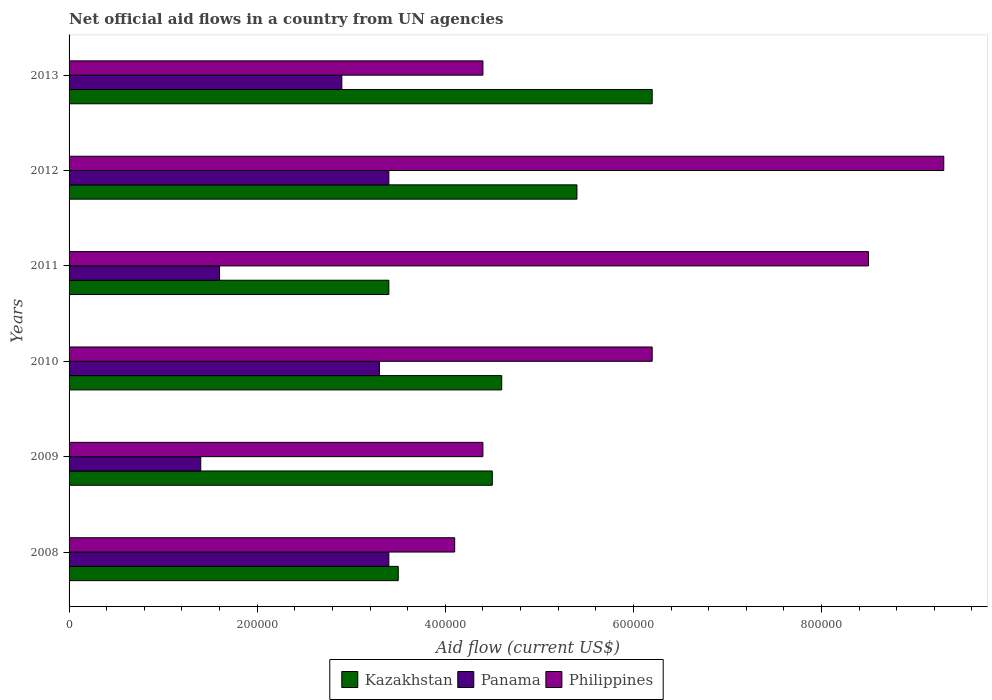How many different coloured bars are there?
Ensure brevity in your answer.  3. How many groups of bars are there?
Your answer should be compact. 6. Are the number of bars per tick equal to the number of legend labels?
Keep it short and to the point. Yes. Are the number of bars on each tick of the Y-axis equal?
Ensure brevity in your answer.  Yes. How many bars are there on the 1st tick from the top?
Offer a very short reply. 3. What is the net official aid flow in Kazakhstan in 2009?
Offer a very short reply. 4.50e+05. Across all years, what is the maximum net official aid flow in Panama?
Ensure brevity in your answer.  3.40e+05. Across all years, what is the minimum net official aid flow in Panama?
Ensure brevity in your answer.  1.40e+05. In which year was the net official aid flow in Panama minimum?
Provide a succinct answer. 2009. What is the total net official aid flow in Kazakhstan in the graph?
Provide a short and direct response. 2.76e+06. What is the difference between the net official aid flow in Kazakhstan in 2008 and that in 2012?
Make the answer very short. -1.90e+05. What is the difference between the net official aid flow in Kazakhstan in 2009 and the net official aid flow in Panama in 2012?
Offer a terse response. 1.10e+05. What is the average net official aid flow in Panama per year?
Offer a very short reply. 2.67e+05. In the year 2011, what is the difference between the net official aid flow in Kazakhstan and net official aid flow in Philippines?
Your answer should be very brief. -5.10e+05. In how many years, is the net official aid flow in Philippines greater than 760000 US$?
Your response must be concise. 2. What is the ratio of the net official aid flow in Philippines in 2008 to that in 2009?
Offer a very short reply. 0.93. Is the net official aid flow in Panama in 2008 less than that in 2013?
Provide a succinct answer. No. Is the difference between the net official aid flow in Kazakhstan in 2008 and 2011 greater than the difference between the net official aid flow in Philippines in 2008 and 2011?
Your answer should be compact. Yes. What is the difference between the highest and the lowest net official aid flow in Kazakhstan?
Your answer should be compact. 2.80e+05. In how many years, is the net official aid flow in Panama greater than the average net official aid flow in Panama taken over all years?
Provide a succinct answer. 4. What does the 3rd bar from the bottom in 2009 represents?
Your answer should be compact. Philippines. Is it the case that in every year, the sum of the net official aid flow in Philippines and net official aid flow in Panama is greater than the net official aid flow in Kazakhstan?
Make the answer very short. Yes. How many years are there in the graph?
Give a very brief answer. 6. What is the difference between two consecutive major ticks on the X-axis?
Provide a short and direct response. 2.00e+05. Does the graph contain any zero values?
Your answer should be compact. No. Does the graph contain grids?
Offer a very short reply. No. Where does the legend appear in the graph?
Offer a terse response. Bottom center. How many legend labels are there?
Ensure brevity in your answer.  3. What is the title of the graph?
Offer a very short reply. Net official aid flows in a country from UN agencies. What is the Aid flow (current US$) in Kazakhstan in 2008?
Your answer should be compact. 3.50e+05. What is the Aid flow (current US$) of Philippines in 2008?
Offer a very short reply. 4.10e+05. What is the Aid flow (current US$) of Panama in 2009?
Provide a short and direct response. 1.40e+05. What is the Aid flow (current US$) of Philippines in 2009?
Your answer should be compact. 4.40e+05. What is the Aid flow (current US$) in Panama in 2010?
Offer a terse response. 3.30e+05. What is the Aid flow (current US$) of Philippines in 2010?
Offer a terse response. 6.20e+05. What is the Aid flow (current US$) of Kazakhstan in 2011?
Give a very brief answer. 3.40e+05. What is the Aid flow (current US$) of Panama in 2011?
Ensure brevity in your answer.  1.60e+05. What is the Aid flow (current US$) of Philippines in 2011?
Provide a short and direct response. 8.50e+05. What is the Aid flow (current US$) of Kazakhstan in 2012?
Offer a very short reply. 5.40e+05. What is the Aid flow (current US$) of Panama in 2012?
Provide a short and direct response. 3.40e+05. What is the Aid flow (current US$) of Philippines in 2012?
Your response must be concise. 9.30e+05. What is the Aid flow (current US$) of Kazakhstan in 2013?
Offer a terse response. 6.20e+05. What is the Aid flow (current US$) of Philippines in 2013?
Your answer should be compact. 4.40e+05. Across all years, what is the maximum Aid flow (current US$) in Kazakhstan?
Ensure brevity in your answer.  6.20e+05. Across all years, what is the maximum Aid flow (current US$) in Panama?
Offer a very short reply. 3.40e+05. Across all years, what is the maximum Aid flow (current US$) in Philippines?
Your answer should be compact. 9.30e+05. Across all years, what is the minimum Aid flow (current US$) in Panama?
Give a very brief answer. 1.40e+05. Across all years, what is the minimum Aid flow (current US$) in Philippines?
Offer a terse response. 4.10e+05. What is the total Aid flow (current US$) of Kazakhstan in the graph?
Your answer should be compact. 2.76e+06. What is the total Aid flow (current US$) in Panama in the graph?
Provide a succinct answer. 1.60e+06. What is the total Aid flow (current US$) in Philippines in the graph?
Your answer should be very brief. 3.69e+06. What is the difference between the Aid flow (current US$) in Kazakhstan in 2008 and that in 2009?
Provide a short and direct response. -1.00e+05. What is the difference between the Aid flow (current US$) of Panama in 2008 and that in 2010?
Make the answer very short. 10000. What is the difference between the Aid flow (current US$) of Philippines in 2008 and that in 2010?
Give a very brief answer. -2.10e+05. What is the difference between the Aid flow (current US$) in Kazakhstan in 2008 and that in 2011?
Give a very brief answer. 10000. What is the difference between the Aid flow (current US$) in Philippines in 2008 and that in 2011?
Ensure brevity in your answer.  -4.40e+05. What is the difference between the Aid flow (current US$) of Kazakhstan in 2008 and that in 2012?
Provide a succinct answer. -1.90e+05. What is the difference between the Aid flow (current US$) in Panama in 2008 and that in 2012?
Your response must be concise. 0. What is the difference between the Aid flow (current US$) of Philippines in 2008 and that in 2012?
Your answer should be compact. -5.20e+05. What is the difference between the Aid flow (current US$) of Kazakhstan in 2008 and that in 2013?
Ensure brevity in your answer.  -2.70e+05. What is the difference between the Aid flow (current US$) in Kazakhstan in 2009 and that in 2010?
Provide a short and direct response. -10000. What is the difference between the Aid flow (current US$) of Panama in 2009 and that in 2011?
Keep it short and to the point. -2.00e+04. What is the difference between the Aid flow (current US$) of Philippines in 2009 and that in 2011?
Ensure brevity in your answer.  -4.10e+05. What is the difference between the Aid flow (current US$) in Kazakhstan in 2009 and that in 2012?
Provide a succinct answer. -9.00e+04. What is the difference between the Aid flow (current US$) in Philippines in 2009 and that in 2012?
Provide a short and direct response. -4.90e+05. What is the difference between the Aid flow (current US$) in Philippines in 2009 and that in 2013?
Provide a succinct answer. 0. What is the difference between the Aid flow (current US$) in Panama in 2010 and that in 2011?
Your response must be concise. 1.70e+05. What is the difference between the Aid flow (current US$) of Philippines in 2010 and that in 2011?
Make the answer very short. -2.30e+05. What is the difference between the Aid flow (current US$) in Philippines in 2010 and that in 2012?
Ensure brevity in your answer.  -3.10e+05. What is the difference between the Aid flow (current US$) in Panama in 2010 and that in 2013?
Ensure brevity in your answer.  4.00e+04. What is the difference between the Aid flow (current US$) of Philippines in 2010 and that in 2013?
Your answer should be compact. 1.80e+05. What is the difference between the Aid flow (current US$) in Kazakhstan in 2011 and that in 2012?
Your response must be concise. -2.00e+05. What is the difference between the Aid flow (current US$) of Philippines in 2011 and that in 2012?
Your answer should be compact. -8.00e+04. What is the difference between the Aid flow (current US$) in Kazakhstan in 2011 and that in 2013?
Provide a succinct answer. -2.80e+05. What is the difference between the Aid flow (current US$) in Panama in 2012 and that in 2013?
Ensure brevity in your answer.  5.00e+04. What is the difference between the Aid flow (current US$) in Philippines in 2012 and that in 2013?
Your answer should be compact. 4.90e+05. What is the difference between the Aid flow (current US$) of Kazakhstan in 2008 and the Aid flow (current US$) of Panama in 2009?
Offer a terse response. 2.10e+05. What is the difference between the Aid flow (current US$) in Panama in 2008 and the Aid flow (current US$) in Philippines in 2009?
Keep it short and to the point. -1.00e+05. What is the difference between the Aid flow (current US$) in Kazakhstan in 2008 and the Aid flow (current US$) in Philippines in 2010?
Provide a short and direct response. -2.70e+05. What is the difference between the Aid flow (current US$) in Panama in 2008 and the Aid flow (current US$) in Philippines in 2010?
Your answer should be compact. -2.80e+05. What is the difference between the Aid flow (current US$) of Kazakhstan in 2008 and the Aid flow (current US$) of Philippines in 2011?
Your answer should be compact. -5.00e+05. What is the difference between the Aid flow (current US$) in Panama in 2008 and the Aid flow (current US$) in Philippines in 2011?
Give a very brief answer. -5.10e+05. What is the difference between the Aid flow (current US$) of Kazakhstan in 2008 and the Aid flow (current US$) of Philippines in 2012?
Your response must be concise. -5.80e+05. What is the difference between the Aid flow (current US$) of Panama in 2008 and the Aid flow (current US$) of Philippines in 2012?
Provide a short and direct response. -5.90e+05. What is the difference between the Aid flow (current US$) in Kazakhstan in 2008 and the Aid flow (current US$) in Philippines in 2013?
Make the answer very short. -9.00e+04. What is the difference between the Aid flow (current US$) of Kazakhstan in 2009 and the Aid flow (current US$) of Panama in 2010?
Offer a terse response. 1.20e+05. What is the difference between the Aid flow (current US$) of Kazakhstan in 2009 and the Aid flow (current US$) of Philippines in 2010?
Your response must be concise. -1.70e+05. What is the difference between the Aid flow (current US$) of Panama in 2009 and the Aid flow (current US$) of Philippines in 2010?
Provide a short and direct response. -4.80e+05. What is the difference between the Aid flow (current US$) in Kazakhstan in 2009 and the Aid flow (current US$) in Panama in 2011?
Ensure brevity in your answer.  2.90e+05. What is the difference between the Aid flow (current US$) in Kazakhstan in 2009 and the Aid flow (current US$) in Philippines in 2011?
Your response must be concise. -4.00e+05. What is the difference between the Aid flow (current US$) of Panama in 2009 and the Aid flow (current US$) of Philippines in 2011?
Keep it short and to the point. -7.10e+05. What is the difference between the Aid flow (current US$) in Kazakhstan in 2009 and the Aid flow (current US$) in Philippines in 2012?
Your response must be concise. -4.80e+05. What is the difference between the Aid flow (current US$) of Panama in 2009 and the Aid flow (current US$) of Philippines in 2012?
Give a very brief answer. -7.90e+05. What is the difference between the Aid flow (current US$) in Panama in 2009 and the Aid flow (current US$) in Philippines in 2013?
Your response must be concise. -3.00e+05. What is the difference between the Aid flow (current US$) in Kazakhstan in 2010 and the Aid flow (current US$) in Philippines in 2011?
Offer a very short reply. -3.90e+05. What is the difference between the Aid flow (current US$) of Panama in 2010 and the Aid flow (current US$) of Philippines in 2011?
Your answer should be very brief. -5.20e+05. What is the difference between the Aid flow (current US$) in Kazakhstan in 2010 and the Aid flow (current US$) in Panama in 2012?
Ensure brevity in your answer.  1.20e+05. What is the difference between the Aid flow (current US$) of Kazakhstan in 2010 and the Aid flow (current US$) of Philippines in 2012?
Give a very brief answer. -4.70e+05. What is the difference between the Aid flow (current US$) of Panama in 2010 and the Aid flow (current US$) of Philippines in 2012?
Your answer should be very brief. -6.00e+05. What is the difference between the Aid flow (current US$) of Kazakhstan in 2010 and the Aid flow (current US$) of Philippines in 2013?
Keep it short and to the point. 2.00e+04. What is the difference between the Aid flow (current US$) in Panama in 2010 and the Aid flow (current US$) in Philippines in 2013?
Keep it short and to the point. -1.10e+05. What is the difference between the Aid flow (current US$) in Kazakhstan in 2011 and the Aid flow (current US$) in Panama in 2012?
Your response must be concise. 0. What is the difference between the Aid flow (current US$) in Kazakhstan in 2011 and the Aid flow (current US$) in Philippines in 2012?
Offer a very short reply. -5.90e+05. What is the difference between the Aid flow (current US$) in Panama in 2011 and the Aid flow (current US$) in Philippines in 2012?
Give a very brief answer. -7.70e+05. What is the difference between the Aid flow (current US$) in Panama in 2011 and the Aid flow (current US$) in Philippines in 2013?
Ensure brevity in your answer.  -2.80e+05. What is the difference between the Aid flow (current US$) of Kazakhstan in 2012 and the Aid flow (current US$) of Panama in 2013?
Make the answer very short. 2.50e+05. What is the average Aid flow (current US$) in Panama per year?
Offer a terse response. 2.67e+05. What is the average Aid flow (current US$) of Philippines per year?
Provide a short and direct response. 6.15e+05. In the year 2010, what is the difference between the Aid flow (current US$) in Panama and Aid flow (current US$) in Philippines?
Your answer should be very brief. -2.90e+05. In the year 2011, what is the difference between the Aid flow (current US$) of Kazakhstan and Aid flow (current US$) of Philippines?
Your response must be concise. -5.10e+05. In the year 2011, what is the difference between the Aid flow (current US$) in Panama and Aid flow (current US$) in Philippines?
Your response must be concise. -6.90e+05. In the year 2012, what is the difference between the Aid flow (current US$) in Kazakhstan and Aid flow (current US$) in Philippines?
Keep it short and to the point. -3.90e+05. In the year 2012, what is the difference between the Aid flow (current US$) in Panama and Aid flow (current US$) in Philippines?
Your response must be concise. -5.90e+05. In the year 2013, what is the difference between the Aid flow (current US$) of Kazakhstan and Aid flow (current US$) of Philippines?
Provide a short and direct response. 1.80e+05. In the year 2013, what is the difference between the Aid flow (current US$) in Panama and Aid flow (current US$) in Philippines?
Provide a short and direct response. -1.50e+05. What is the ratio of the Aid flow (current US$) of Panama in 2008 to that in 2009?
Offer a very short reply. 2.43. What is the ratio of the Aid flow (current US$) in Philippines in 2008 to that in 2009?
Offer a terse response. 0.93. What is the ratio of the Aid flow (current US$) of Kazakhstan in 2008 to that in 2010?
Ensure brevity in your answer.  0.76. What is the ratio of the Aid flow (current US$) in Panama in 2008 to that in 2010?
Your response must be concise. 1.03. What is the ratio of the Aid flow (current US$) of Philippines in 2008 to that in 2010?
Your response must be concise. 0.66. What is the ratio of the Aid flow (current US$) in Kazakhstan in 2008 to that in 2011?
Make the answer very short. 1.03. What is the ratio of the Aid flow (current US$) of Panama in 2008 to that in 2011?
Give a very brief answer. 2.12. What is the ratio of the Aid flow (current US$) of Philippines in 2008 to that in 2011?
Your answer should be very brief. 0.48. What is the ratio of the Aid flow (current US$) in Kazakhstan in 2008 to that in 2012?
Provide a succinct answer. 0.65. What is the ratio of the Aid flow (current US$) of Panama in 2008 to that in 2012?
Make the answer very short. 1. What is the ratio of the Aid flow (current US$) of Philippines in 2008 to that in 2012?
Offer a terse response. 0.44. What is the ratio of the Aid flow (current US$) in Kazakhstan in 2008 to that in 2013?
Your response must be concise. 0.56. What is the ratio of the Aid flow (current US$) in Panama in 2008 to that in 2013?
Your answer should be compact. 1.17. What is the ratio of the Aid flow (current US$) of Philippines in 2008 to that in 2013?
Your answer should be very brief. 0.93. What is the ratio of the Aid flow (current US$) of Kazakhstan in 2009 to that in 2010?
Provide a short and direct response. 0.98. What is the ratio of the Aid flow (current US$) in Panama in 2009 to that in 2010?
Give a very brief answer. 0.42. What is the ratio of the Aid flow (current US$) in Philippines in 2009 to that in 2010?
Keep it short and to the point. 0.71. What is the ratio of the Aid flow (current US$) in Kazakhstan in 2009 to that in 2011?
Make the answer very short. 1.32. What is the ratio of the Aid flow (current US$) in Panama in 2009 to that in 2011?
Keep it short and to the point. 0.88. What is the ratio of the Aid flow (current US$) in Philippines in 2009 to that in 2011?
Offer a very short reply. 0.52. What is the ratio of the Aid flow (current US$) in Kazakhstan in 2009 to that in 2012?
Ensure brevity in your answer.  0.83. What is the ratio of the Aid flow (current US$) of Panama in 2009 to that in 2012?
Your answer should be compact. 0.41. What is the ratio of the Aid flow (current US$) of Philippines in 2009 to that in 2012?
Your answer should be compact. 0.47. What is the ratio of the Aid flow (current US$) in Kazakhstan in 2009 to that in 2013?
Your response must be concise. 0.73. What is the ratio of the Aid flow (current US$) of Panama in 2009 to that in 2013?
Your response must be concise. 0.48. What is the ratio of the Aid flow (current US$) of Kazakhstan in 2010 to that in 2011?
Offer a terse response. 1.35. What is the ratio of the Aid flow (current US$) in Panama in 2010 to that in 2011?
Your answer should be compact. 2.06. What is the ratio of the Aid flow (current US$) in Philippines in 2010 to that in 2011?
Your answer should be very brief. 0.73. What is the ratio of the Aid flow (current US$) of Kazakhstan in 2010 to that in 2012?
Give a very brief answer. 0.85. What is the ratio of the Aid flow (current US$) of Panama in 2010 to that in 2012?
Provide a short and direct response. 0.97. What is the ratio of the Aid flow (current US$) in Kazakhstan in 2010 to that in 2013?
Provide a succinct answer. 0.74. What is the ratio of the Aid flow (current US$) in Panama in 2010 to that in 2013?
Your answer should be very brief. 1.14. What is the ratio of the Aid flow (current US$) in Philippines in 2010 to that in 2013?
Offer a terse response. 1.41. What is the ratio of the Aid flow (current US$) in Kazakhstan in 2011 to that in 2012?
Keep it short and to the point. 0.63. What is the ratio of the Aid flow (current US$) of Panama in 2011 to that in 2012?
Make the answer very short. 0.47. What is the ratio of the Aid flow (current US$) in Philippines in 2011 to that in 2012?
Provide a succinct answer. 0.91. What is the ratio of the Aid flow (current US$) in Kazakhstan in 2011 to that in 2013?
Offer a very short reply. 0.55. What is the ratio of the Aid flow (current US$) of Panama in 2011 to that in 2013?
Provide a short and direct response. 0.55. What is the ratio of the Aid flow (current US$) of Philippines in 2011 to that in 2013?
Offer a very short reply. 1.93. What is the ratio of the Aid flow (current US$) of Kazakhstan in 2012 to that in 2013?
Make the answer very short. 0.87. What is the ratio of the Aid flow (current US$) of Panama in 2012 to that in 2013?
Keep it short and to the point. 1.17. What is the ratio of the Aid flow (current US$) of Philippines in 2012 to that in 2013?
Offer a very short reply. 2.11. What is the difference between the highest and the second highest Aid flow (current US$) of Kazakhstan?
Offer a terse response. 8.00e+04. What is the difference between the highest and the second highest Aid flow (current US$) of Panama?
Make the answer very short. 0. What is the difference between the highest and the lowest Aid flow (current US$) of Kazakhstan?
Give a very brief answer. 2.80e+05. What is the difference between the highest and the lowest Aid flow (current US$) in Philippines?
Your response must be concise. 5.20e+05. 